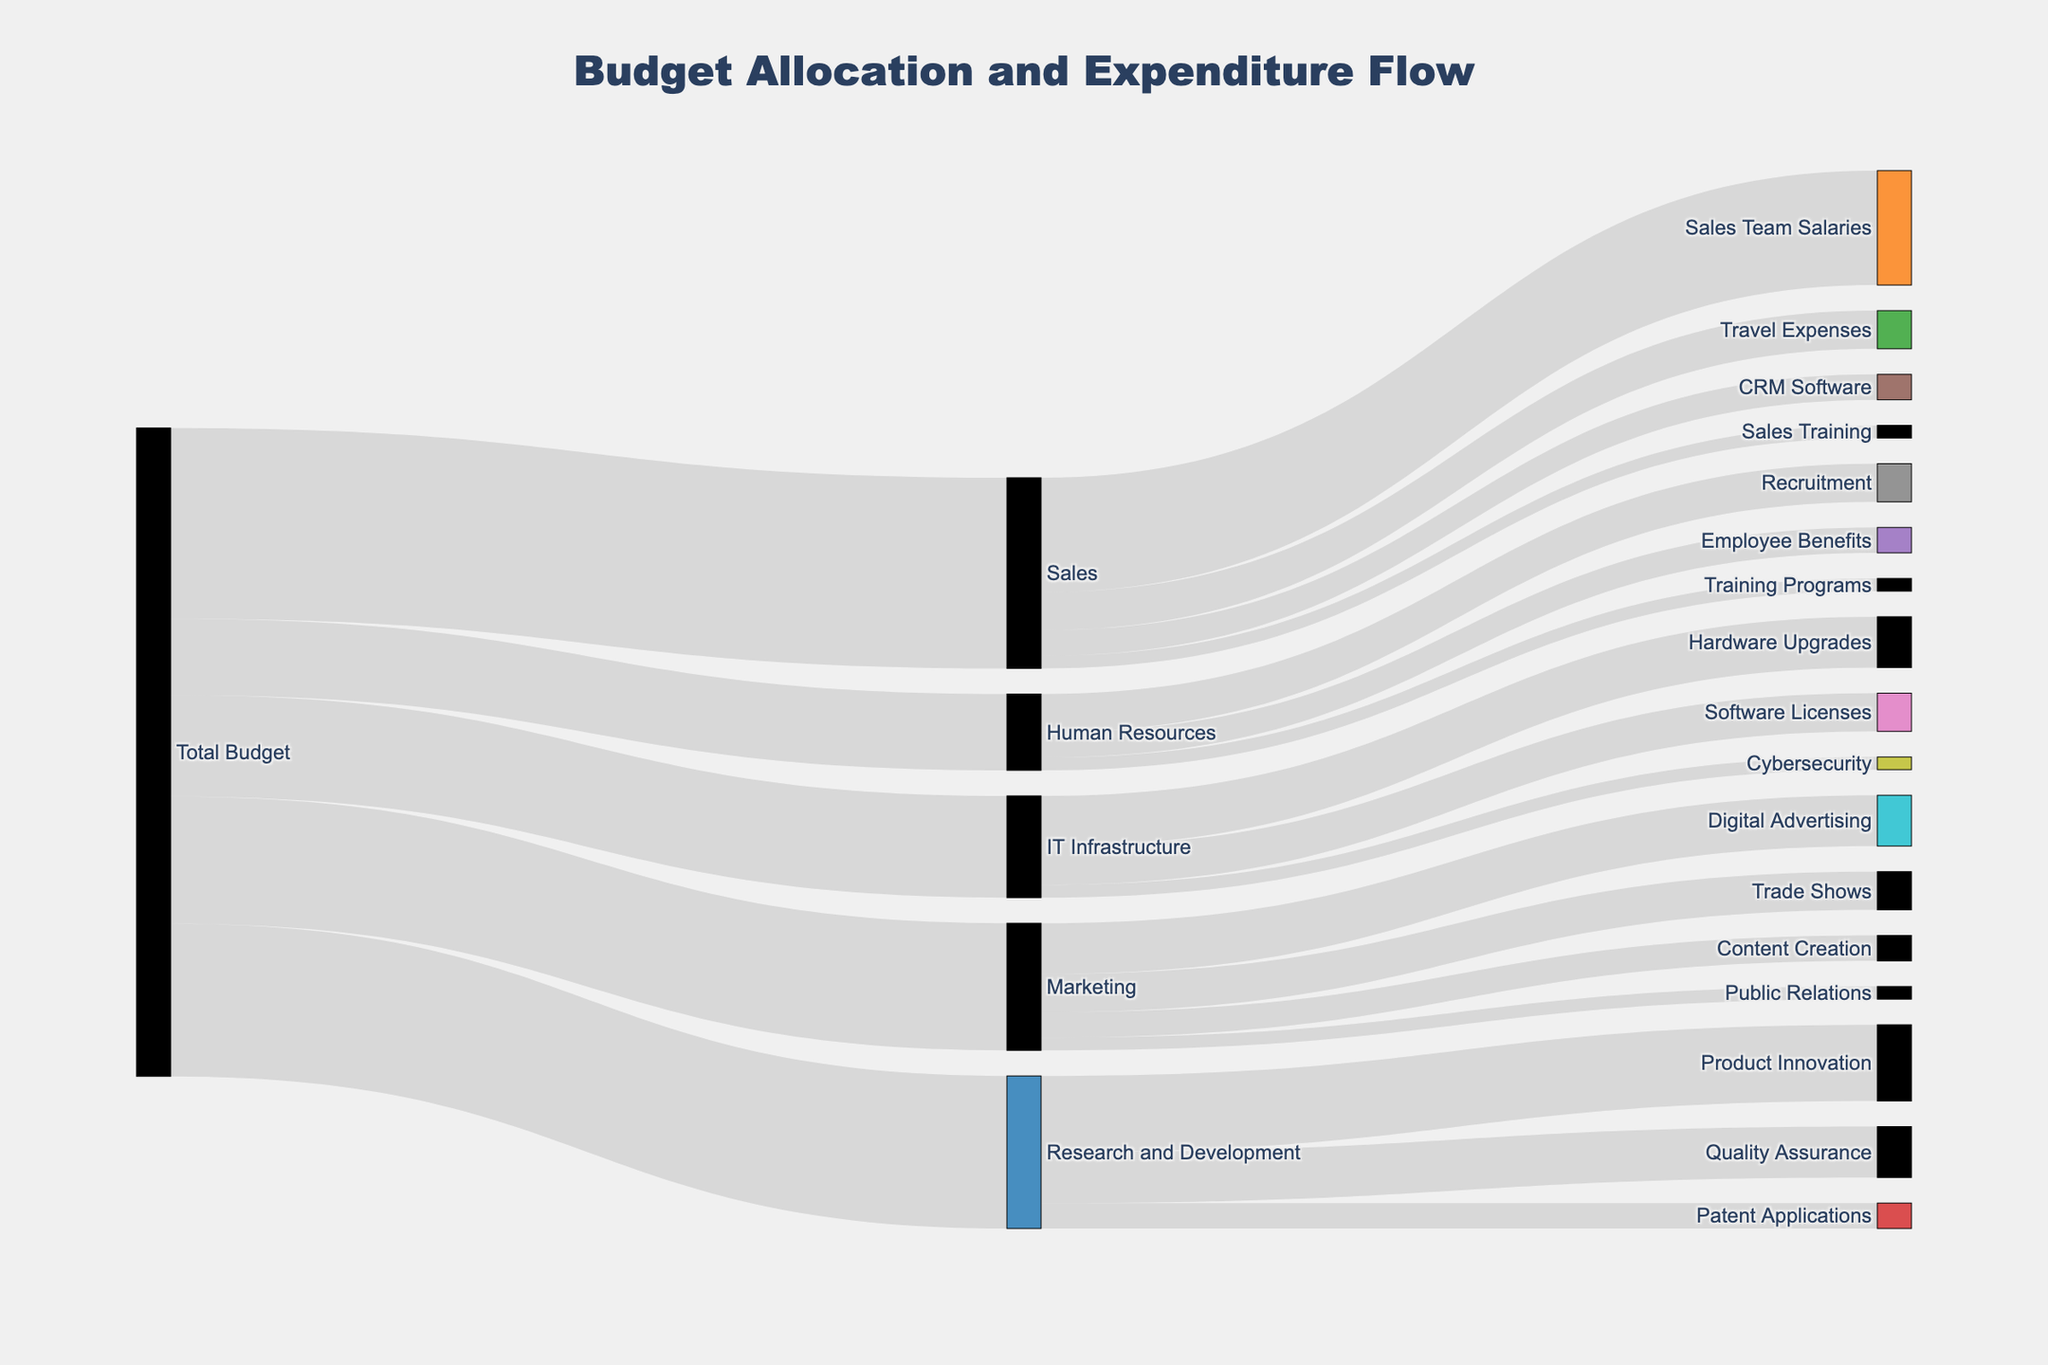What is the total budget allocated to Marketing? The Sankey diagram shows that the total budget allocated to Marketing originates from the "Total Budget" node and is represented by the value connecting these two nodes. This value is 500,000.
Answer: 500,000 What is the largest expenditure in the Sales department? By looking at the connections from the Sales node, we can see the different values allocated to its expenditures. The largest value linked to Sales is "Sales Team Salaries" with 450,000.
Answer: Sales Team Salaries How much budget is allocated to IT Infrastructure and its subcategories combined? The IT Infrastructure node receives a total budget of 400,000 from Total Budget. Adding its subcategories: Hardware Upgrades (200,000), Software Licenses (150,000), and Cybersecurity (50,000) gives a combined value of 400,000.
Answer: 400,000 Which department receives the most significant share of the total budget? Comparing the values from the Total Budget node to each department, Sales receives the highest value with 750,000.
Answer: Sales How does the budget allocation for Recruitment compare to Employee Benefits in the Human Resources department? In the Human Resources node, Recruitment receives 150,000 while Employee Benefits receives 100,000. Recruitment has a higher allocation.
Answer: Recruitment has a higher allocation than Employee Benefits What percentage of the total budget is allocated to Research and Development? The total budget across all nodes sums to 2,550,000. Research and Development receives 600,000. The percentage is calculated by (600,000/2,550,000) * 100 = approximately 23.53%.
Answer: Approximately 23.53% How much more is spent on Travel Expenses compared to CRM Software in the Sales department? Travel Expenses is allocated 150,000 while CRM Software receives 100,000. The difference is 150,000 - 100,000 = 50,000.
Answer: 50,000 Which subcategory in Marketing receives the least funding? Looking at the allocations from the Marketing node, Public Relations receives the least funding at 50,000.
Answer: Public Relations What is the sum of all expenditures in Research and Development? Adding all subcategory values in Research and Development: Product Innovation (300,000), Quality Assurance (200,000), and Patent Applications (100,000) gives a total of 600,000.
Answer: 600,000 Compare the total budget allocated to IT Infrastructure with that allocated to Human Resources. IT Infrastructure receives 400,000 and Human Resources receives 300,000 from the Total Budget. IT Infrastructure has a higher allocation by 100,000 (400,000 - 300,000).
Answer: IT Infrastructure receives 100,000 more than Human Resources 